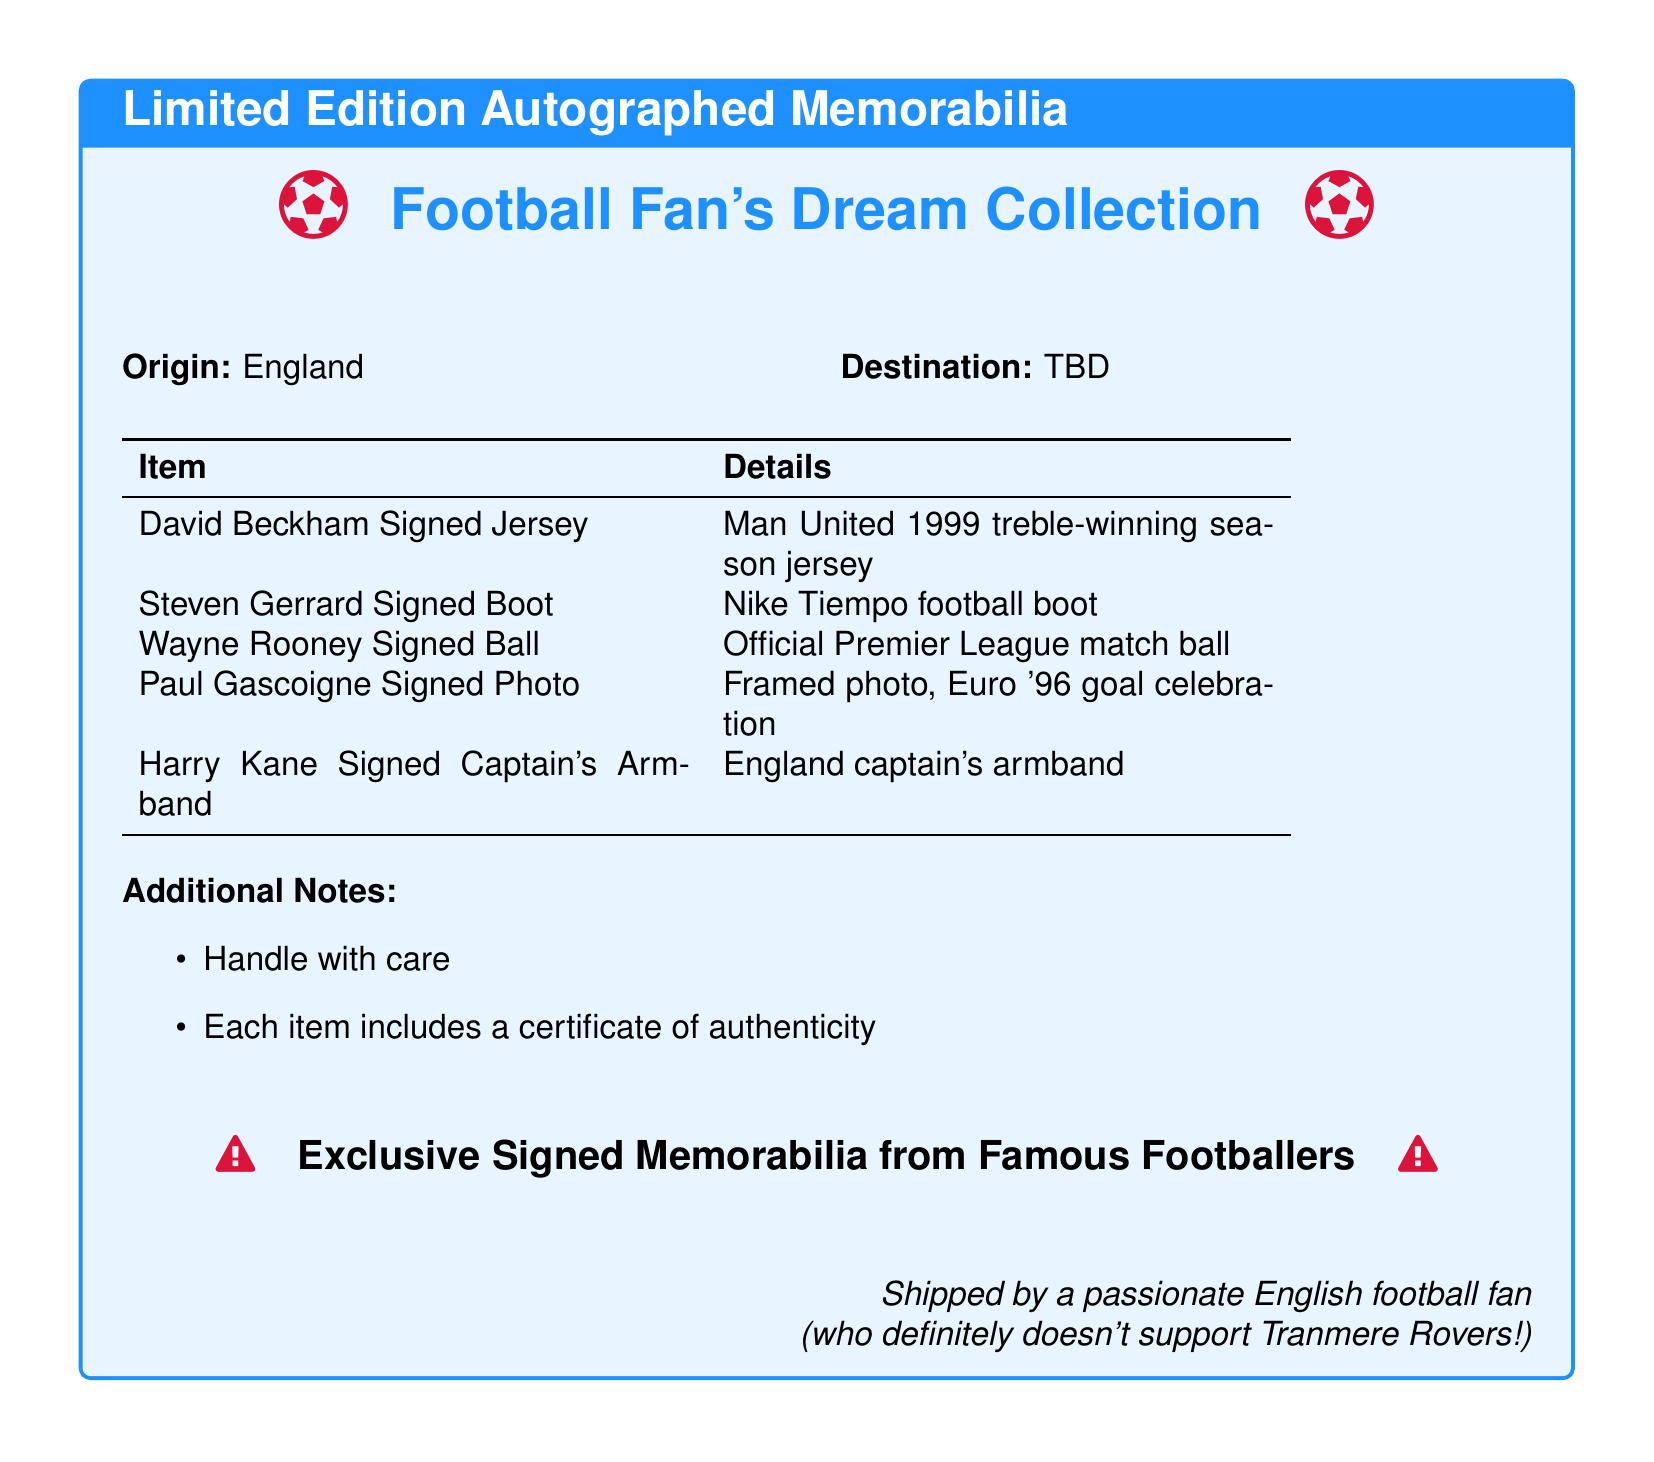What is the origin of the items? The document states that the origin of the items is in England.
Answer: England What is featured along with each signed memorabilia item? Each item comes with a certificate of authenticity.
Answer: Certificate of authenticity Who signed the jersey mentioned? The jersey mentioned was signed by David Beckham.
Answer: David Beckham What type of boot is signed by Steven Gerrard? The signed boot is a Nike Tiempo football boot.
Answer: Nike Tiempo football boot What is the significance of the armband signed by Harry Kane? The armband is significant as it is an England captain's armband.
Answer: England captain's armband How many items are listed in total? The document lists a total of five items under the memorabilia collection.
Answer: Five What color theme is used in the title box? The color theme combines footyblue and footyred colors.
Answer: footyblue and footyred What does the additional note advise regarding handling? The additional note advises to handle the items with care.
Answer: Handle with care Who shipped the memorabilia? The document mentions that it is shipped by a passionate English football fan.
Answer: A passionate English football fan 